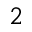<formula> <loc_0><loc_0><loc_500><loc_500>_ { 2 }</formula> 